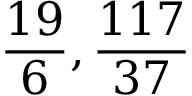<formula> <loc_0><loc_0><loc_500><loc_500>{ \frac { 1 9 } { 6 } } , { \frac { 1 1 7 } { 3 7 } }</formula> 